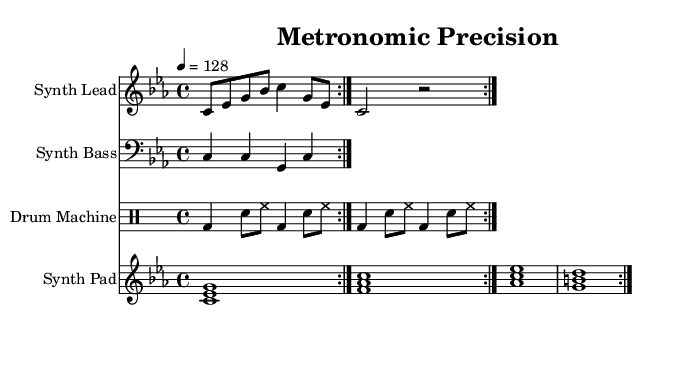What is the key signature of this music? The key signature is C minor, which has three flats (B flat, E flat, and A flat) indicated by the bass clef.
Answer: C minor What is the time signature of this music? The time signature is 4/4, which is indicated at the beginning of the score, showing four beats in each measure.
Answer: 4/4 What is the tempo marking of this piece? The tempo marking is 128 beats per minute, which is specified under the tempo instruction in the score.
Answer: 128 How many measures are in the synth lead section? The synth lead section consists of 4 measures, as each volta (repeat) section indicates repeated phrases encompassing two measures each, totaling four.
Answer: 4 Which instrument plays the drum pattern? The drum pattern is played by the drum machine, which is specified in the staff name in the music score.
Answer: Drum Machine What type of attack is used in the synth pad chords? The synth pad plays sustained chords, indicated by the whole notes in the score, which means the notes are held for their full duration.
Answer: Sustained How does the bass pattern contribute to the House music style? The bass pattern uses a rhythmic, repetitive motif characteristic of House music, reinforcing the groove with a simple, driving eighth-note rhythm.
Answer: Rhythmic, repetitive 